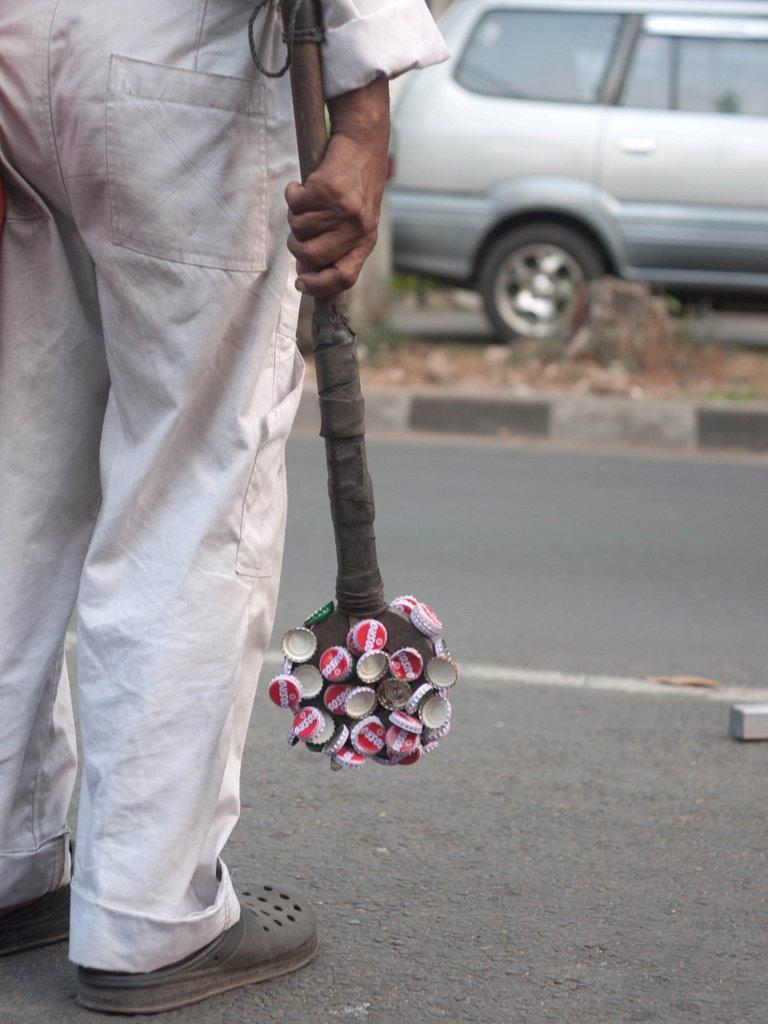What is the main subject of the image? There is a person in the image. What is the person holding in the image? The person is holding an object with bottle lids. Can you describe any other objects or vehicles in the image? Yes, there is a car in the image. What type of pipe can be seen in the image? There is no pipe present in the image. How many wrens are visible in the image? There are no wrens present in the image. 